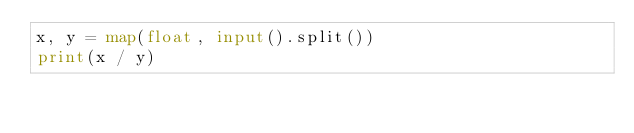Convert code to text. <code><loc_0><loc_0><loc_500><loc_500><_Python_>x, y = map(float, input().split())
print(x / y)</code> 